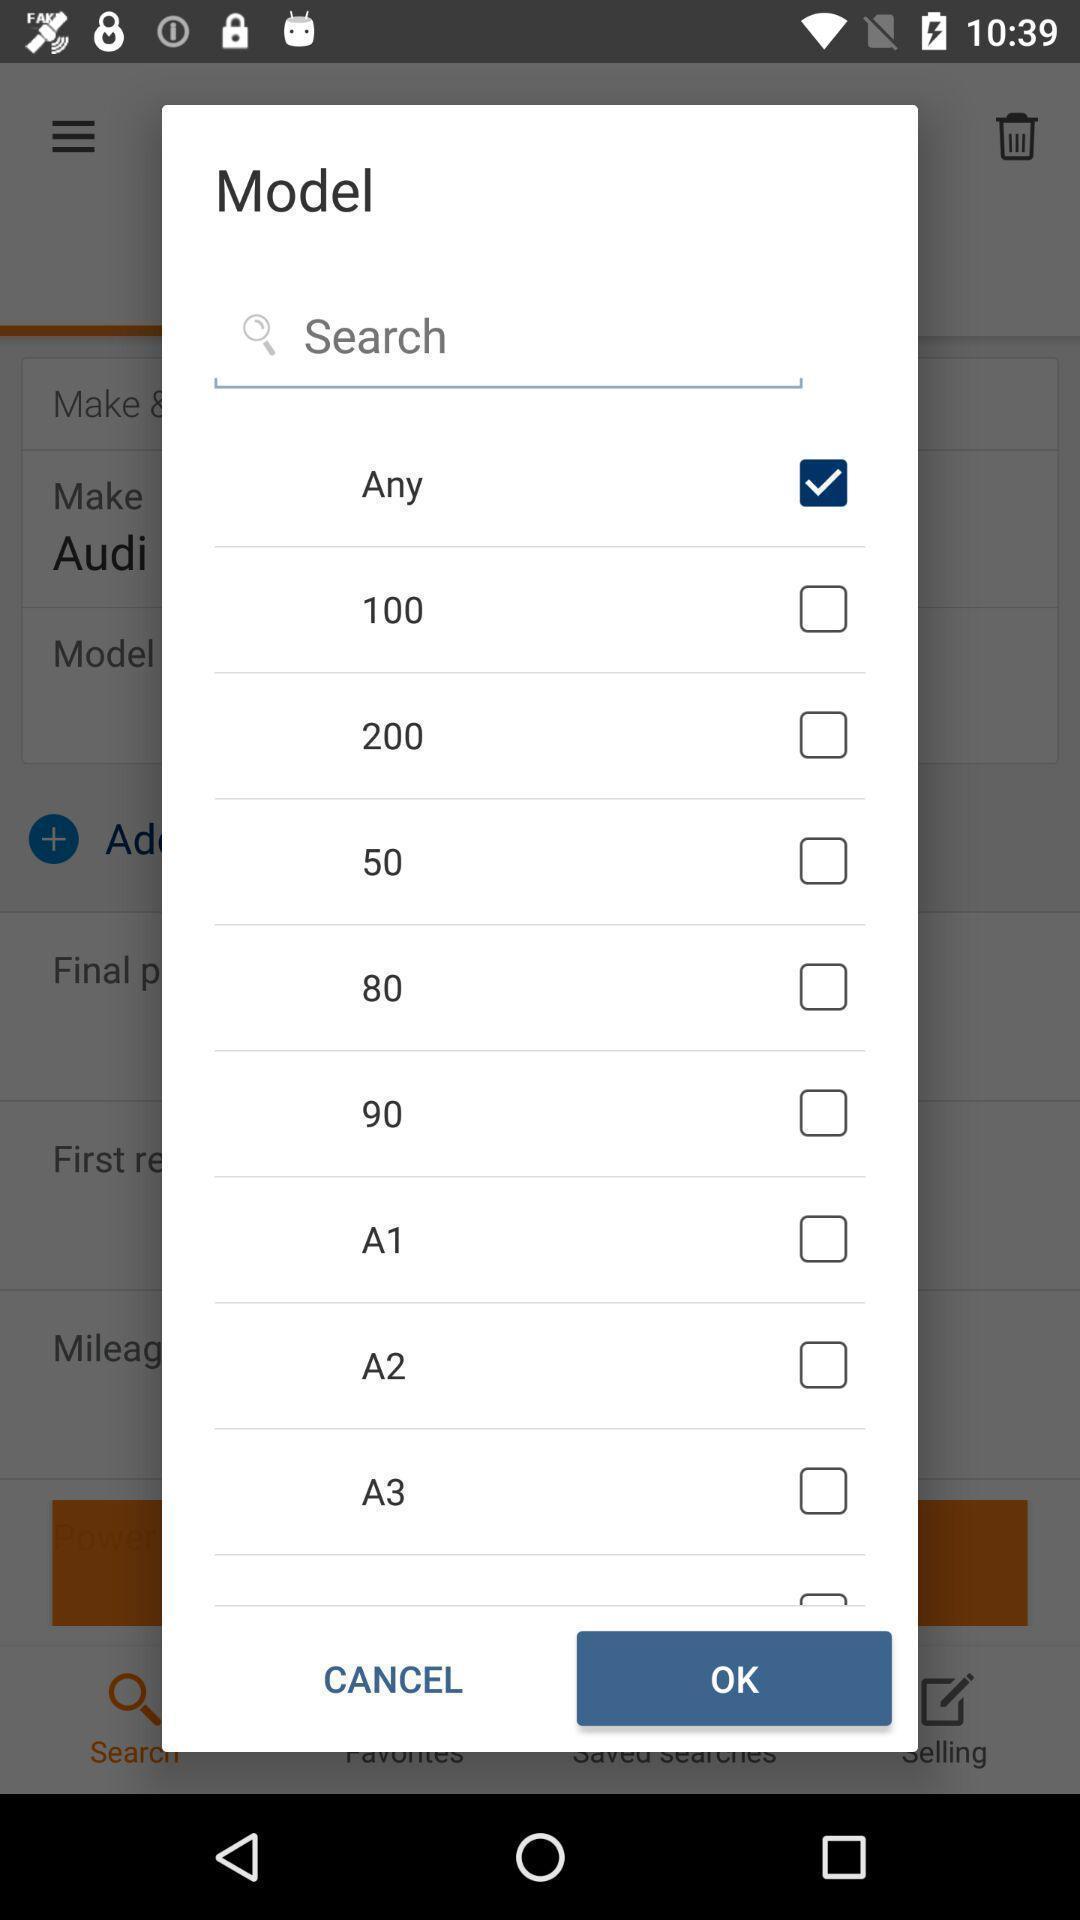Describe this image in words. Popup showing list of model numbers. 